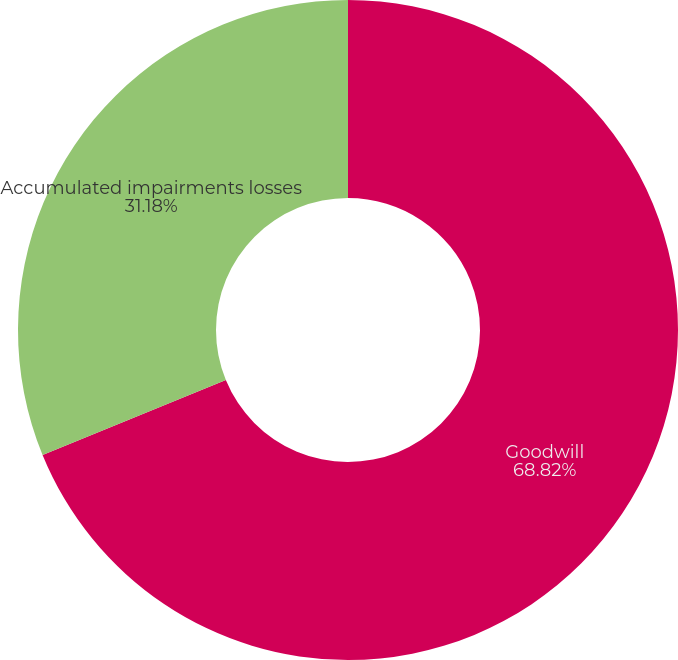Convert chart to OTSL. <chart><loc_0><loc_0><loc_500><loc_500><pie_chart><fcel>Goodwill<fcel>Accumulated impairments losses<nl><fcel>68.82%<fcel>31.18%<nl></chart> 